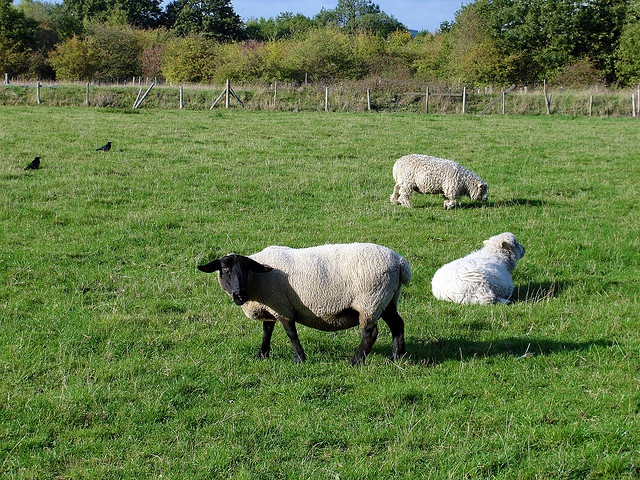Describe the objects in this image and their specific colors. I can see sheep in darkgreen, black, lightgray, darkgray, and gray tones, sheep in darkgreen, white, darkgray, and gray tones, sheep in darkgreen, lightgray, darkgray, gray, and black tones, bird in darkgreen, black, and green tones, and bird in darkgreen, black, olive, and gray tones in this image. 